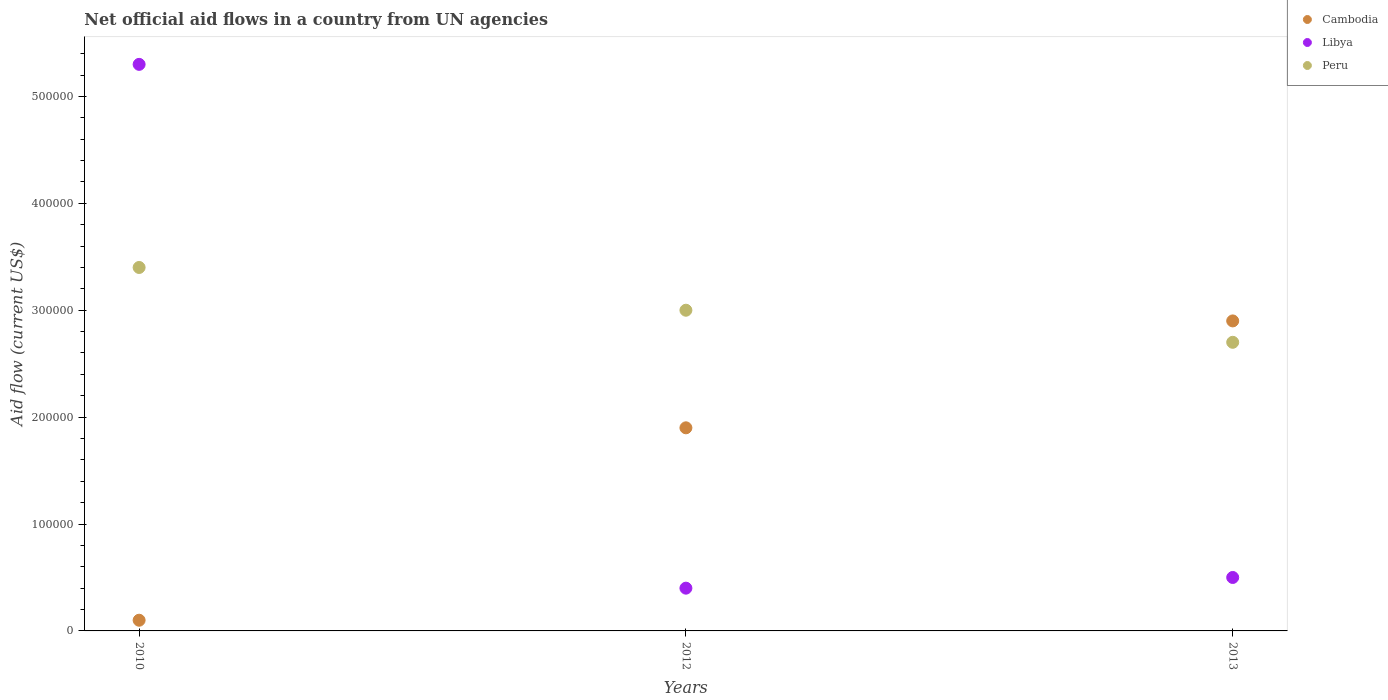Is the number of dotlines equal to the number of legend labels?
Your answer should be compact. Yes. Across all years, what is the maximum net official aid flow in Libya?
Provide a short and direct response. 5.30e+05. Across all years, what is the minimum net official aid flow in Libya?
Make the answer very short. 4.00e+04. In which year was the net official aid flow in Libya minimum?
Your answer should be very brief. 2012. What is the total net official aid flow in Libya in the graph?
Make the answer very short. 6.20e+05. What is the difference between the net official aid flow in Cambodia in 2010 and that in 2013?
Your response must be concise. -2.80e+05. What is the average net official aid flow in Peru per year?
Make the answer very short. 3.03e+05. In the year 2013, what is the difference between the net official aid flow in Cambodia and net official aid flow in Libya?
Offer a terse response. 2.40e+05. What is the ratio of the net official aid flow in Libya in 2012 to that in 2013?
Give a very brief answer. 0.8. Is the net official aid flow in Libya in 2010 less than that in 2012?
Provide a succinct answer. No. Is the difference between the net official aid flow in Cambodia in 2012 and 2013 greater than the difference between the net official aid flow in Libya in 2012 and 2013?
Keep it short and to the point. No. What is the difference between the highest and the lowest net official aid flow in Libya?
Your answer should be very brief. 4.90e+05. In how many years, is the net official aid flow in Cambodia greater than the average net official aid flow in Cambodia taken over all years?
Your response must be concise. 2. Is the sum of the net official aid flow in Cambodia in 2012 and 2013 greater than the maximum net official aid flow in Peru across all years?
Your answer should be very brief. Yes. Is it the case that in every year, the sum of the net official aid flow in Cambodia and net official aid flow in Peru  is greater than the net official aid flow in Libya?
Give a very brief answer. No. Is the net official aid flow in Cambodia strictly less than the net official aid flow in Peru over the years?
Provide a short and direct response. No. How many years are there in the graph?
Your answer should be very brief. 3. Are the values on the major ticks of Y-axis written in scientific E-notation?
Provide a short and direct response. No. Does the graph contain any zero values?
Your answer should be compact. No. Where does the legend appear in the graph?
Your response must be concise. Top right. How many legend labels are there?
Your answer should be very brief. 3. How are the legend labels stacked?
Keep it short and to the point. Vertical. What is the title of the graph?
Give a very brief answer. Net official aid flows in a country from UN agencies. What is the Aid flow (current US$) of Libya in 2010?
Offer a very short reply. 5.30e+05. What is the Aid flow (current US$) in Peru in 2010?
Provide a short and direct response. 3.40e+05. What is the Aid flow (current US$) in Cambodia in 2012?
Give a very brief answer. 1.90e+05. What is the Aid flow (current US$) of Libya in 2012?
Give a very brief answer. 4.00e+04. What is the Aid flow (current US$) in Cambodia in 2013?
Your answer should be compact. 2.90e+05. What is the Aid flow (current US$) in Peru in 2013?
Offer a very short reply. 2.70e+05. Across all years, what is the maximum Aid flow (current US$) of Cambodia?
Give a very brief answer. 2.90e+05. Across all years, what is the maximum Aid flow (current US$) of Libya?
Give a very brief answer. 5.30e+05. Across all years, what is the minimum Aid flow (current US$) in Cambodia?
Keep it short and to the point. 10000. Across all years, what is the minimum Aid flow (current US$) of Peru?
Keep it short and to the point. 2.70e+05. What is the total Aid flow (current US$) of Cambodia in the graph?
Give a very brief answer. 4.90e+05. What is the total Aid flow (current US$) in Libya in the graph?
Provide a short and direct response. 6.20e+05. What is the total Aid flow (current US$) in Peru in the graph?
Your answer should be compact. 9.10e+05. What is the difference between the Aid flow (current US$) of Cambodia in 2010 and that in 2012?
Your response must be concise. -1.80e+05. What is the difference between the Aid flow (current US$) of Libya in 2010 and that in 2012?
Your response must be concise. 4.90e+05. What is the difference between the Aid flow (current US$) of Peru in 2010 and that in 2012?
Keep it short and to the point. 4.00e+04. What is the difference between the Aid flow (current US$) in Cambodia in 2010 and that in 2013?
Make the answer very short. -2.80e+05. What is the difference between the Aid flow (current US$) of Libya in 2010 and that in 2013?
Offer a terse response. 4.80e+05. What is the difference between the Aid flow (current US$) of Peru in 2010 and that in 2013?
Your answer should be compact. 7.00e+04. What is the difference between the Aid flow (current US$) in Cambodia in 2012 and that in 2013?
Your answer should be compact. -1.00e+05. What is the difference between the Aid flow (current US$) in Peru in 2012 and that in 2013?
Offer a very short reply. 3.00e+04. What is the difference between the Aid flow (current US$) of Cambodia in 2010 and the Aid flow (current US$) of Libya in 2012?
Your response must be concise. -3.00e+04. What is the difference between the Aid flow (current US$) in Libya in 2010 and the Aid flow (current US$) in Peru in 2012?
Provide a short and direct response. 2.30e+05. What is the difference between the Aid flow (current US$) of Libya in 2010 and the Aid flow (current US$) of Peru in 2013?
Your answer should be compact. 2.60e+05. What is the difference between the Aid flow (current US$) in Cambodia in 2012 and the Aid flow (current US$) in Libya in 2013?
Ensure brevity in your answer.  1.40e+05. What is the difference between the Aid flow (current US$) in Cambodia in 2012 and the Aid flow (current US$) in Peru in 2013?
Provide a succinct answer. -8.00e+04. What is the difference between the Aid flow (current US$) of Libya in 2012 and the Aid flow (current US$) of Peru in 2013?
Offer a terse response. -2.30e+05. What is the average Aid flow (current US$) of Cambodia per year?
Provide a succinct answer. 1.63e+05. What is the average Aid flow (current US$) of Libya per year?
Ensure brevity in your answer.  2.07e+05. What is the average Aid flow (current US$) of Peru per year?
Ensure brevity in your answer.  3.03e+05. In the year 2010, what is the difference between the Aid flow (current US$) in Cambodia and Aid flow (current US$) in Libya?
Your answer should be compact. -5.20e+05. In the year 2010, what is the difference between the Aid flow (current US$) in Cambodia and Aid flow (current US$) in Peru?
Ensure brevity in your answer.  -3.30e+05. In the year 2012, what is the difference between the Aid flow (current US$) of Cambodia and Aid flow (current US$) of Libya?
Your response must be concise. 1.50e+05. In the year 2012, what is the difference between the Aid flow (current US$) in Cambodia and Aid flow (current US$) in Peru?
Provide a short and direct response. -1.10e+05. In the year 2013, what is the difference between the Aid flow (current US$) of Cambodia and Aid flow (current US$) of Peru?
Your response must be concise. 2.00e+04. In the year 2013, what is the difference between the Aid flow (current US$) in Libya and Aid flow (current US$) in Peru?
Make the answer very short. -2.20e+05. What is the ratio of the Aid flow (current US$) of Cambodia in 2010 to that in 2012?
Your answer should be very brief. 0.05. What is the ratio of the Aid flow (current US$) in Libya in 2010 to that in 2012?
Offer a very short reply. 13.25. What is the ratio of the Aid flow (current US$) of Peru in 2010 to that in 2012?
Provide a succinct answer. 1.13. What is the ratio of the Aid flow (current US$) of Cambodia in 2010 to that in 2013?
Ensure brevity in your answer.  0.03. What is the ratio of the Aid flow (current US$) of Libya in 2010 to that in 2013?
Provide a short and direct response. 10.6. What is the ratio of the Aid flow (current US$) of Peru in 2010 to that in 2013?
Provide a succinct answer. 1.26. What is the ratio of the Aid flow (current US$) of Cambodia in 2012 to that in 2013?
Ensure brevity in your answer.  0.66. What is the difference between the highest and the second highest Aid flow (current US$) of Cambodia?
Make the answer very short. 1.00e+05. What is the difference between the highest and the second highest Aid flow (current US$) in Peru?
Your answer should be compact. 4.00e+04. What is the difference between the highest and the lowest Aid flow (current US$) in Peru?
Keep it short and to the point. 7.00e+04. 